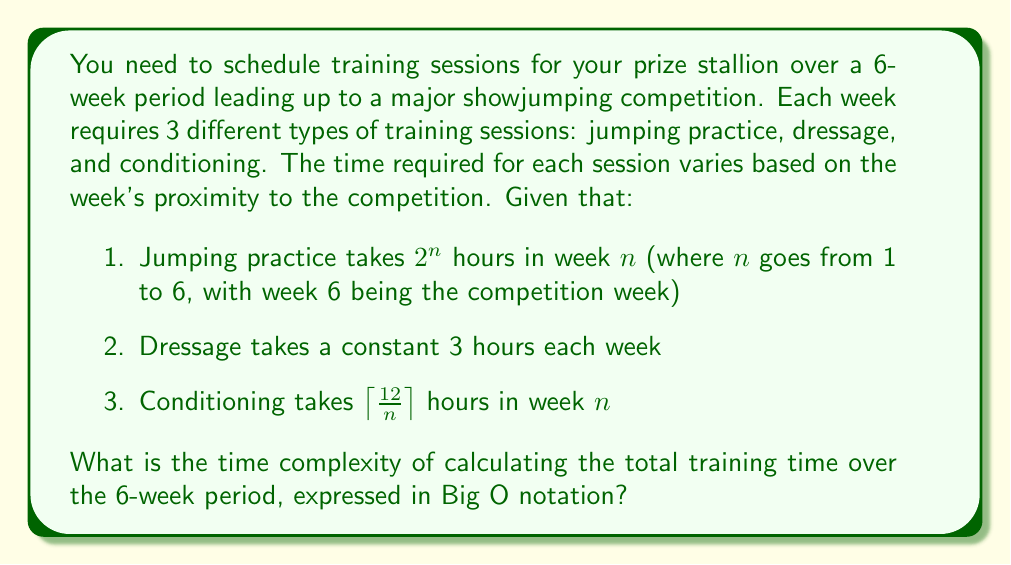Can you answer this question? To determine the time complexity, we need to analyze the operations required to calculate the total training time:

1. Jumping practice:
   We need to calculate $2^n$ for each week. This involves 6 exponentiation operations.
   Time complexity: $O(1)$ (constant time for a fixed number of operations)

2. Dressage:
   This is a constant 3 hours each week, so we simply multiply 3 by 6.
   Time complexity: $O(1)$

3. Conditioning:
   We need to calculate $\lceil \frac{12}{n} \rceil$ for each week. This involves 6 division and ceiling operations.
   Time complexity: $O(1)$

4. Summing up the times:
   We need to add the times for all three types of training for each week, and then sum up the totals for all 6 weeks.
   This requires 18 additions (3 per week for 6 weeks, plus 5 additions to sum the weekly totals).
   Time complexity: $O(1)$

All of these operations are performed a fixed number of times, regardless of the input size. In computational complexity theory, when we have a fixed number of operations that don't depend on the input size, we consider this constant time.

Therefore, the overall time complexity for calculating the total training time is $O(1)$.

It's worth noting that while the actual computation time for $2^n$ grows exponentially with $n$, in complexity analysis, we consider the number of operations rather than the magnitude of the numbers involved. Since we're only doing this calculation 6 times (once for each week), it's still considered constant time in Big O notation.
Answer: $O(1)$ 